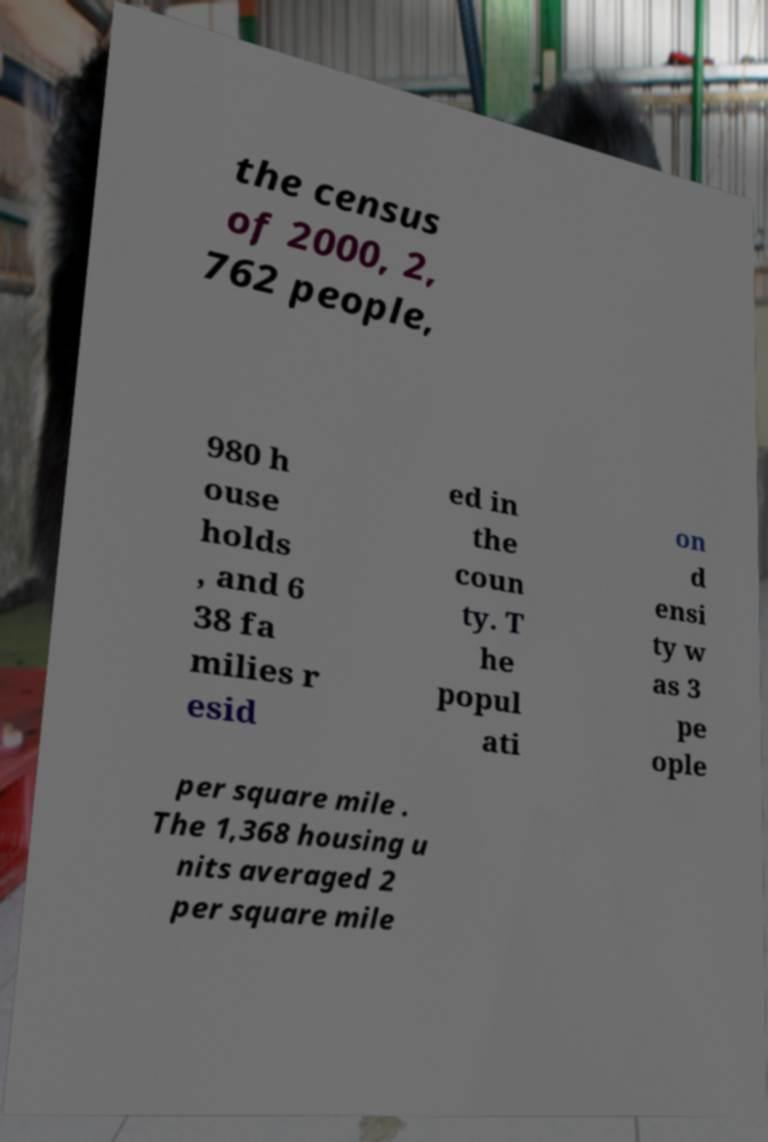Could you assist in decoding the text presented in this image and type it out clearly? the census of 2000, 2, 762 people, 980 h ouse holds , and 6 38 fa milies r esid ed in the coun ty. T he popul ati on d ensi ty w as 3 pe ople per square mile . The 1,368 housing u nits averaged 2 per square mile 